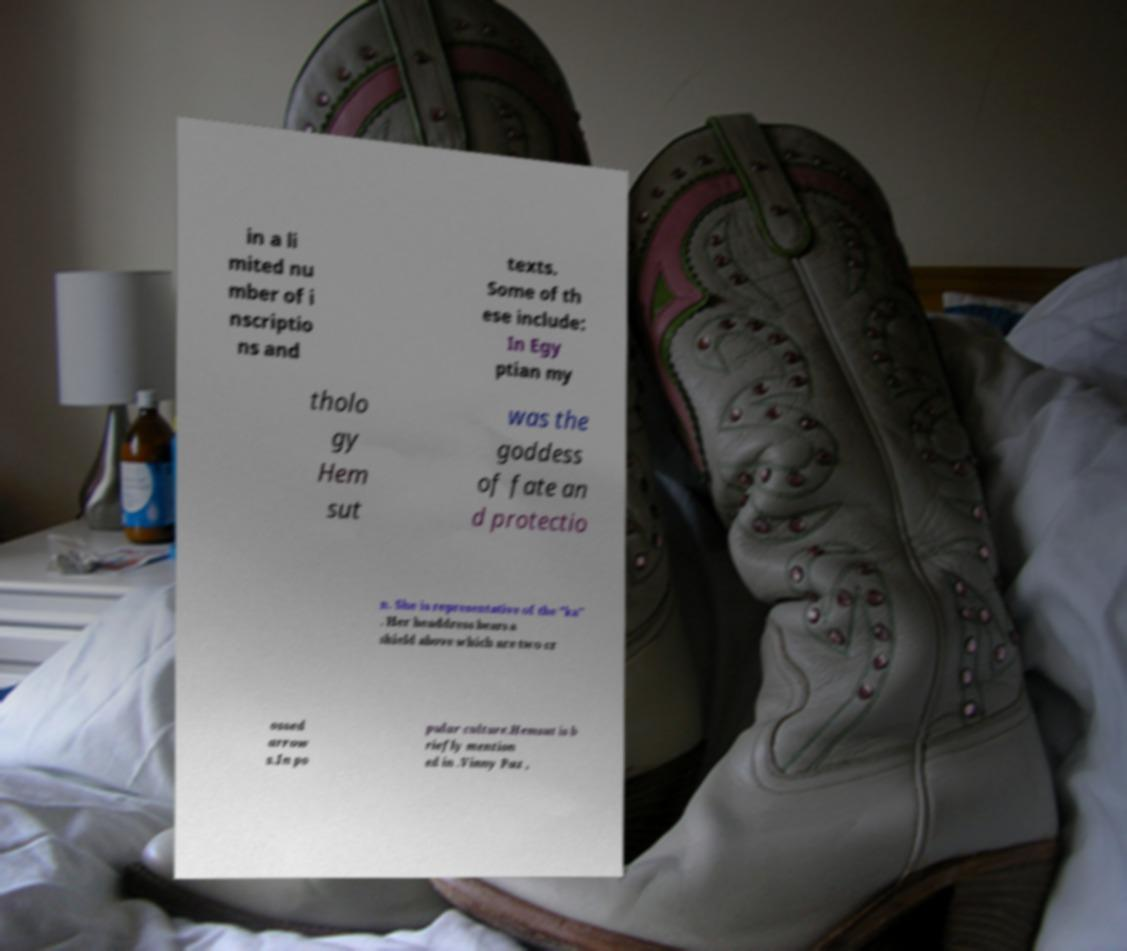Please identify and transcribe the text found in this image. in a li mited nu mber of i nscriptio ns and texts. Some of th ese include: In Egy ptian my tholo gy Hem sut was the goddess of fate an d protectio n. She is representative of the "ka" . Her headdress bears a shield above which are two cr ossed arrow s.In po pular culture.Hemsut is b riefly mention ed in .Vinny Paz , 